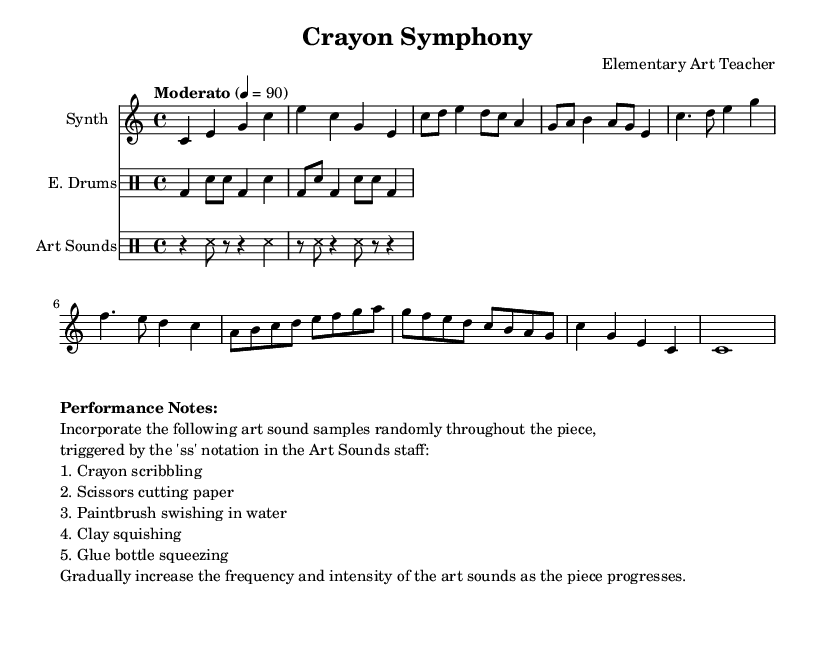What is the key signature of this music? The key signature is indicated at the beginning of the score. It is C major, which has no sharps or flats.
Answer: C major What is the time signature of this piece? The time signature is shown at the start of the score. It is 4/4, meaning there are four beats in a measure.
Answer: 4/4 What is the tempo marking for the composition? The tempo is noted above the staff, stating "Moderato" with a metronome marking of 90 beats per minute. This indicates a moderate speed.
Answer: Moderato, 90 How many measures are in the synthesizer part? By counting the measures in the synthesizer staff, we see that it consists of 8 measures total.
Answer: 8 What types of sounds are included in the art sounds? The performance notes section lists specific art sounds that can be incorporated: crayon scribbling, scissors cutting paper, paintbrush swishing in water, clay squishing, and glue bottle squeezing.
Answer: Crayon scribbling, scissors cutting paper, paintbrush swishing in water, clay squishing, glue bottle squeezing In which section do the art sounds increase in intensity? The performance notes indicate that the frequency and intensity of the art sounds should gradually increase as the piece progresses, but do not specify an exact section. Therefore, it refers to the entire piece as a progression, particularly from the intro through the outro.
Answer: As the piece progresses What is the function of 'ss' in the Art Sounds staff? The 'ss' notation in the Art Sounds staff indicates where to trigger the specific art sounds throughout the piece. It serves as a cue for incorporating those sounds.
Answer: Trigger art sounds 